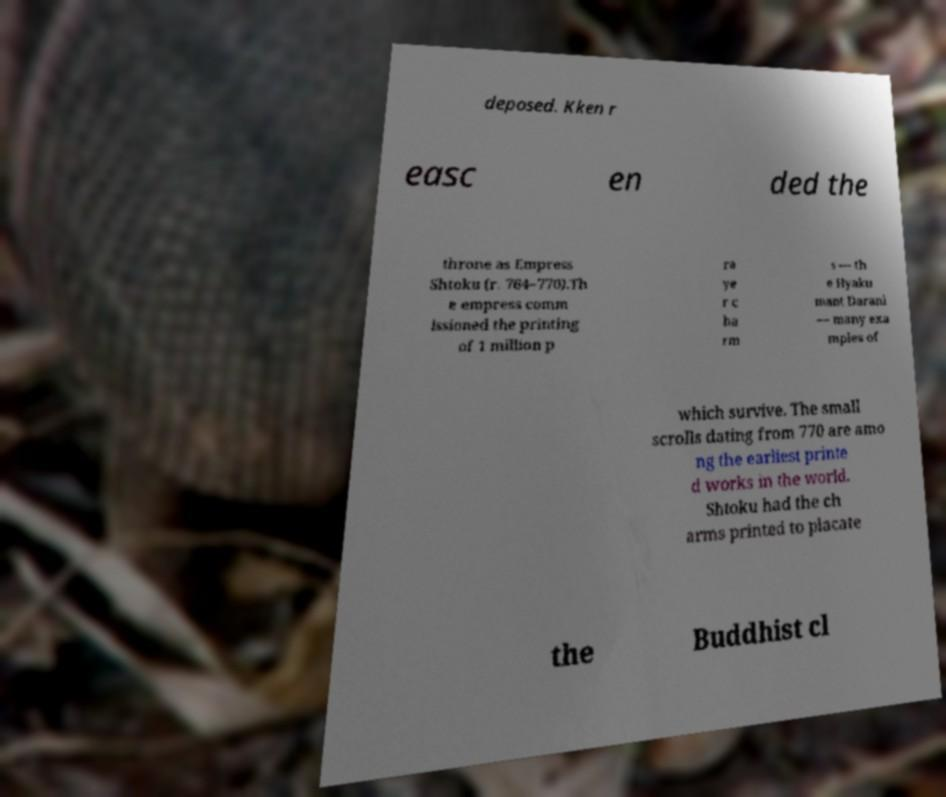What messages or text are displayed in this image? I need them in a readable, typed format. deposed. Kken r easc en ded the throne as Empress Shtoku (r. 764–770).Th e empress comm issioned the printing of 1 million p ra ye r c ha rm s — th e Hyaku mant Darani — many exa mples of which survive. The small scrolls dating from 770 are amo ng the earliest printe d works in the world. Shtoku had the ch arms printed to placate the Buddhist cl 